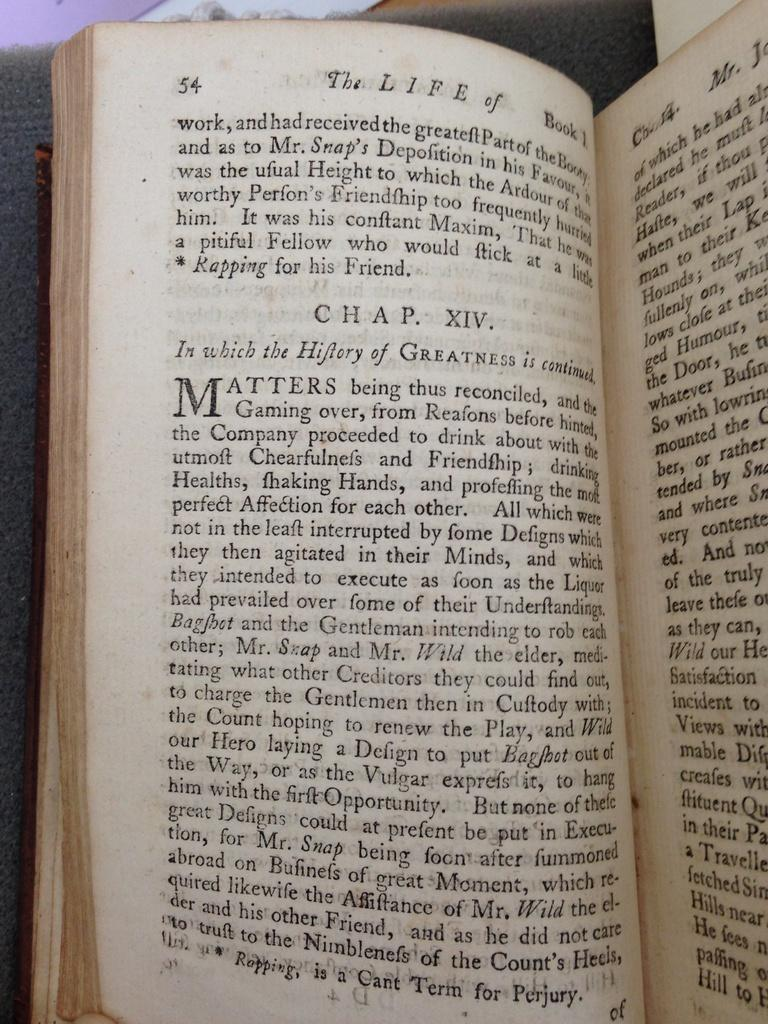<image>
Create a compact narrative representing the image presented. A book is open to page fifty four. 